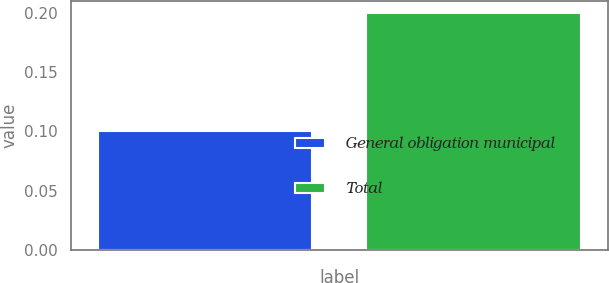Convert chart to OTSL. <chart><loc_0><loc_0><loc_500><loc_500><bar_chart><fcel>General obligation municipal<fcel>Total<nl><fcel>0.1<fcel>0.2<nl></chart> 